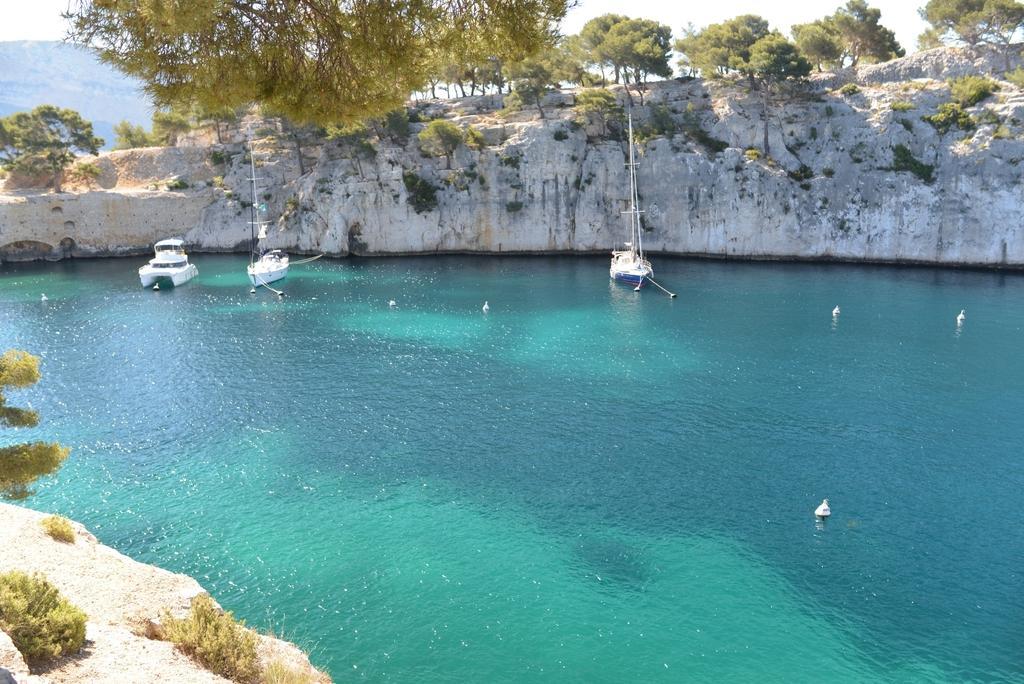Please provide a concise description of this image. In this picture we can see boats on water, rocks, trees, plants, mountains and in the background we can see the sky. 